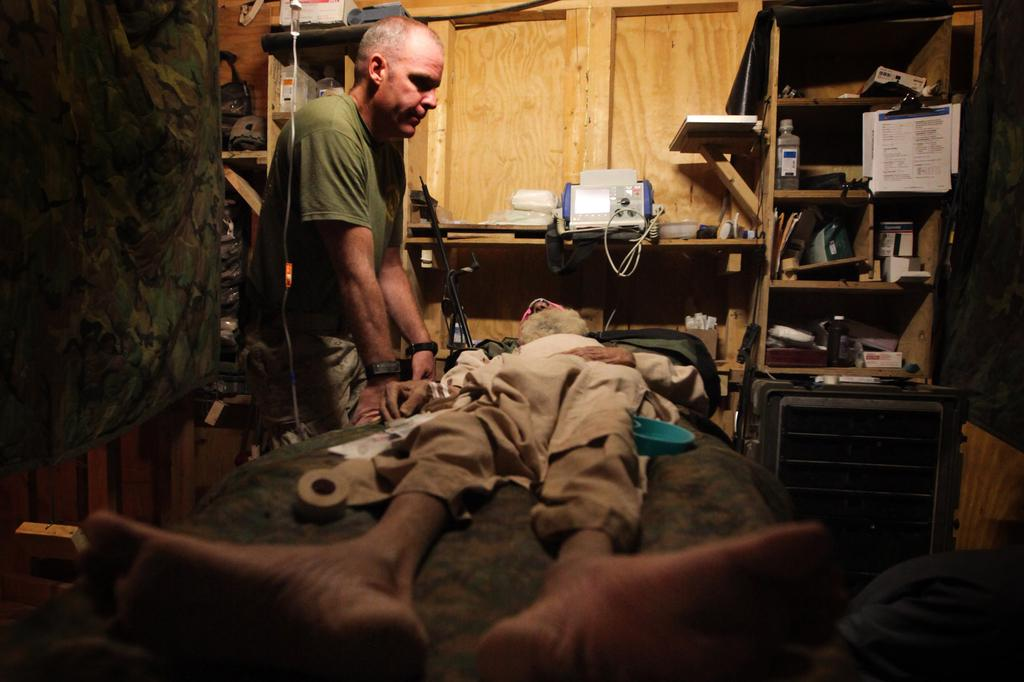What is the main subject of the image? There is a man lying on the bed in the middle of the image. Are there any other people in the image? Yes, there is a man standing on the left side of the image. What can be seen in the background of the image? There are shelves in the background of the image. What is on the shelves in the background? There are items on the shelves in the background. What type of canvas is the man painting on the right side of the image? There is no canvas or painting activity present in the image. How does the man use the brake while standing on the left side of the image? There is no brake or any indication of a vehicle in the image. 